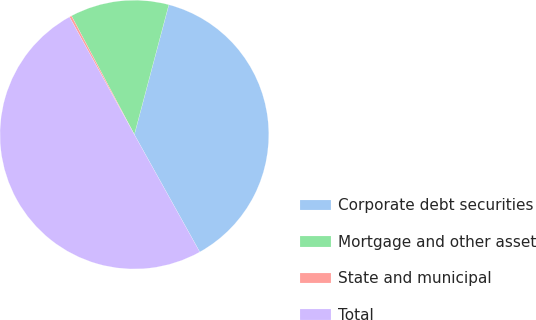<chart> <loc_0><loc_0><loc_500><loc_500><pie_chart><fcel>Corporate debt securities<fcel>Mortgage and other asset<fcel>State and municipal<fcel>Total<nl><fcel>37.78%<fcel>11.88%<fcel>0.27%<fcel>50.07%<nl></chart> 